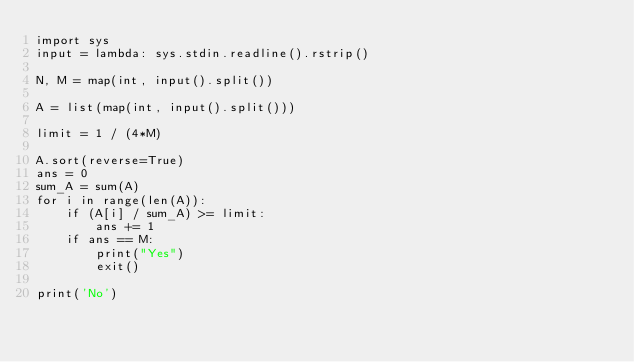<code> <loc_0><loc_0><loc_500><loc_500><_Python_>import sys
input = lambda: sys.stdin.readline().rstrip()

N, M = map(int, input().split())

A = list(map(int, input().split()))

limit = 1 / (4*M)

A.sort(reverse=True)
ans = 0
sum_A = sum(A)
for i in range(len(A)):
    if (A[i] / sum_A) >= limit:
        ans += 1
    if ans == M:
        print("Yes")
        exit()

print('No')</code> 